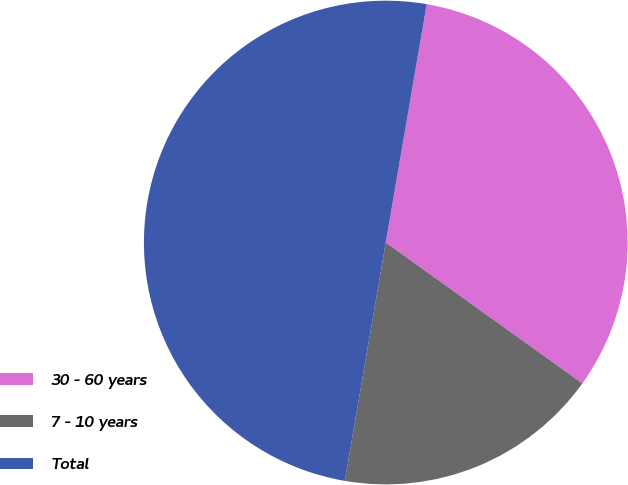<chart> <loc_0><loc_0><loc_500><loc_500><pie_chart><fcel>30 - 60 years<fcel>7 - 10 years<fcel>Total<nl><fcel>32.19%<fcel>17.81%<fcel>50.0%<nl></chart> 